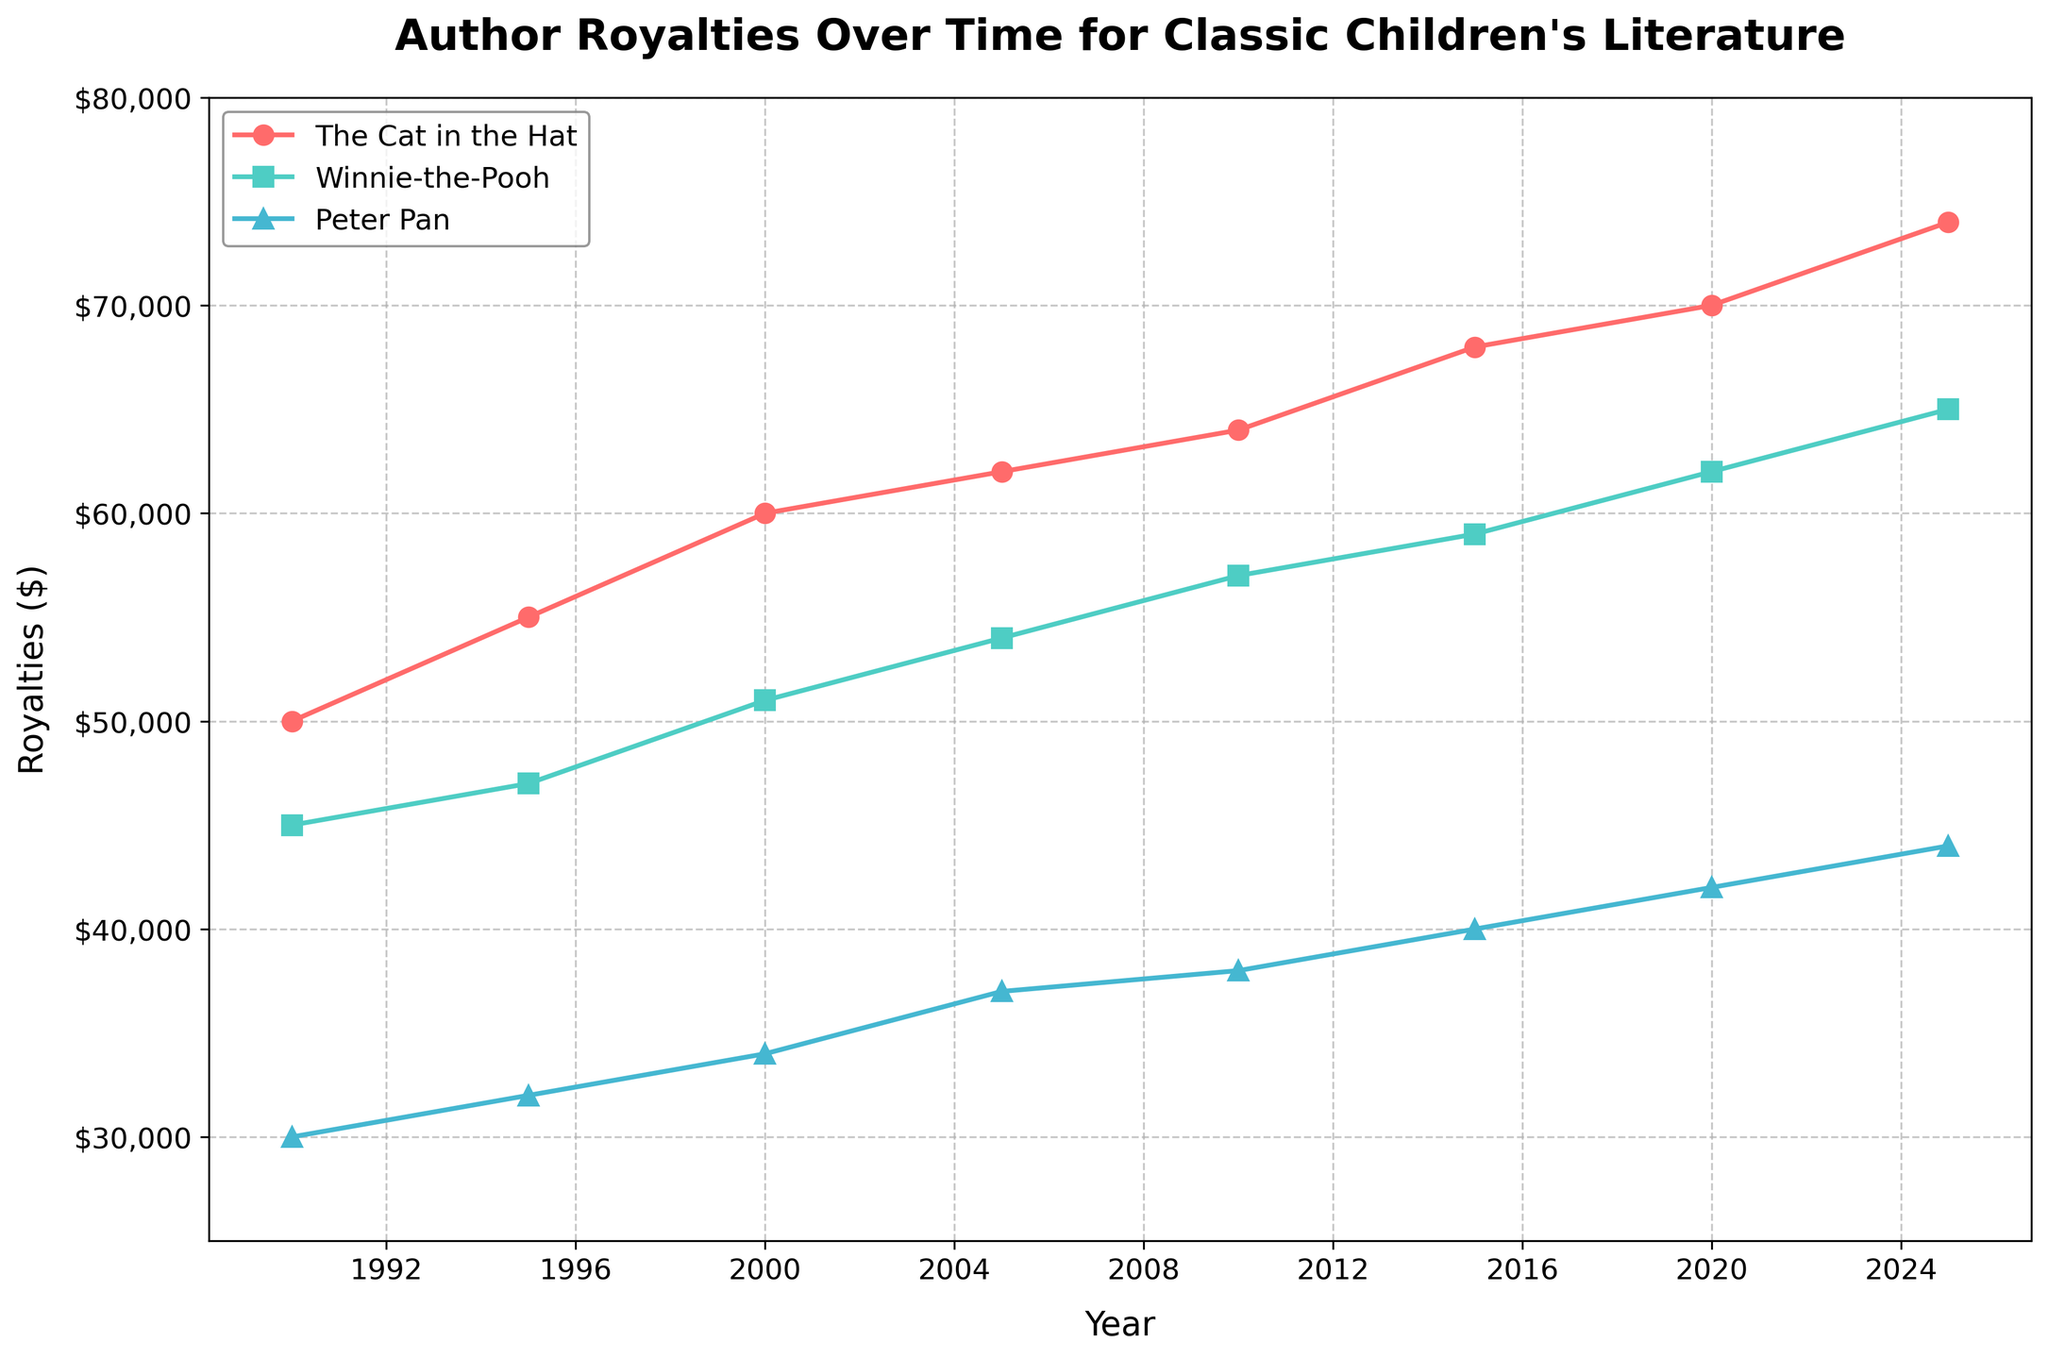what is the title of the plot? The title of the plot is displayed at the top of the figure. It is clear and usually written in a larger, bold font to stand out.
Answer: Author Royalties Over Time for Classic Children's Literature what is the trend of royalties for "The Cat in the Hat" over time? To identify the trend, observe the line corresponding to “The Cat in the Hat” from start to end. See the values increase or decrease over time.
Answer: Increasing which book had the highest royalties in 2020? Locate the point on the x-axis for the year 2020 and compare the heights of the markers for each book. The highest marker represents the highest royalties.
Answer: The Cat in the Hat how did the royalties for "Peter Pan" change from 2000 to 2005? Compare the values of the “Peter Pan” marker at 2000 and 2005. Note whether it increased, decreased, or stayed the same.
Answer: Increased what is the difference in royalties between "The Cat in the Hat" and "Winnie-the-Pooh" in 2025? Look at the royalties for both books in 2025 and subtract “Winnie-the-Pooh”'s value from “The Cat in the Hat”'s value to find the difference.
Answer: $9,000 what was the average royalties for "Winnie-the-Pooh" from 1990 to 2025? Add up the royalties for "Winnie-the-Pooh" at all given years and then divide by the number of data points (7 years). (45,000 + 47,000 + 51,000 + 54,000 + 57,000 + 59,000 + 62,000 + 65,000) / 8 = 52,250
Answer: $52,250 which book demonstrates the most stable increase in royalties over the years? To find the most stable increase, examine which book’s line shows the least fluctuation and the most consistent upward trend over the years.
Answer: The Cat in the Hat how many data points are plotted for each book? Count the markers corresponding to each line for the books. Each book appears to have data points for the years 1990, 1995, 2000, 2005, 2010, 2015, 2020, and 2025.
Answer: 8 between 2005 and 2010, which book saw the greatest increase in royalties? Compare the upward change in value between the two years (2005 and 2010) for each book. The greatest difference indicates the greatest increase.
Answer: Winnie-the-Pooh in which year do "Winnie-the-Pooh" and "Peter Pan" have the closest royalties? Compare the royalties of "Winnie-the-Pooh" and "Peter Pan" across all given years. The smallest difference indicates the closest values.
Answer: 1990 